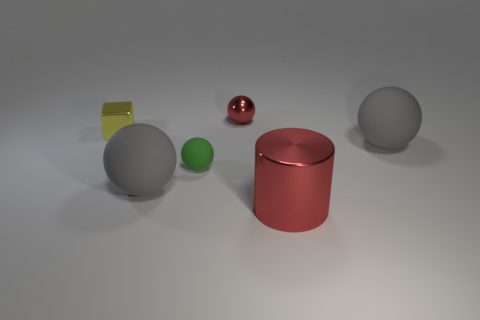Subtract all red metal balls. How many balls are left? 3 Subtract all purple cubes. How many gray spheres are left? 2 Subtract all red spheres. How many spheres are left? 3 Subtract 1 cylinders. How many cylinders are left? 0 Subtract all cubes. How many objects are left? 5 Add 2 yellow metallic things. How many objects exist? 8 Subtract 0 gray cylinders. How many objects are left? 6 Subtract all yellow cylinders. Subtract all brown balls. How many cylinders are left? 1 Subtract all large blue spheres. Subtract all small blocks. How many objects are left? 5 Add 6 tiny red metal things. How many tiny red metal things are left? 7 